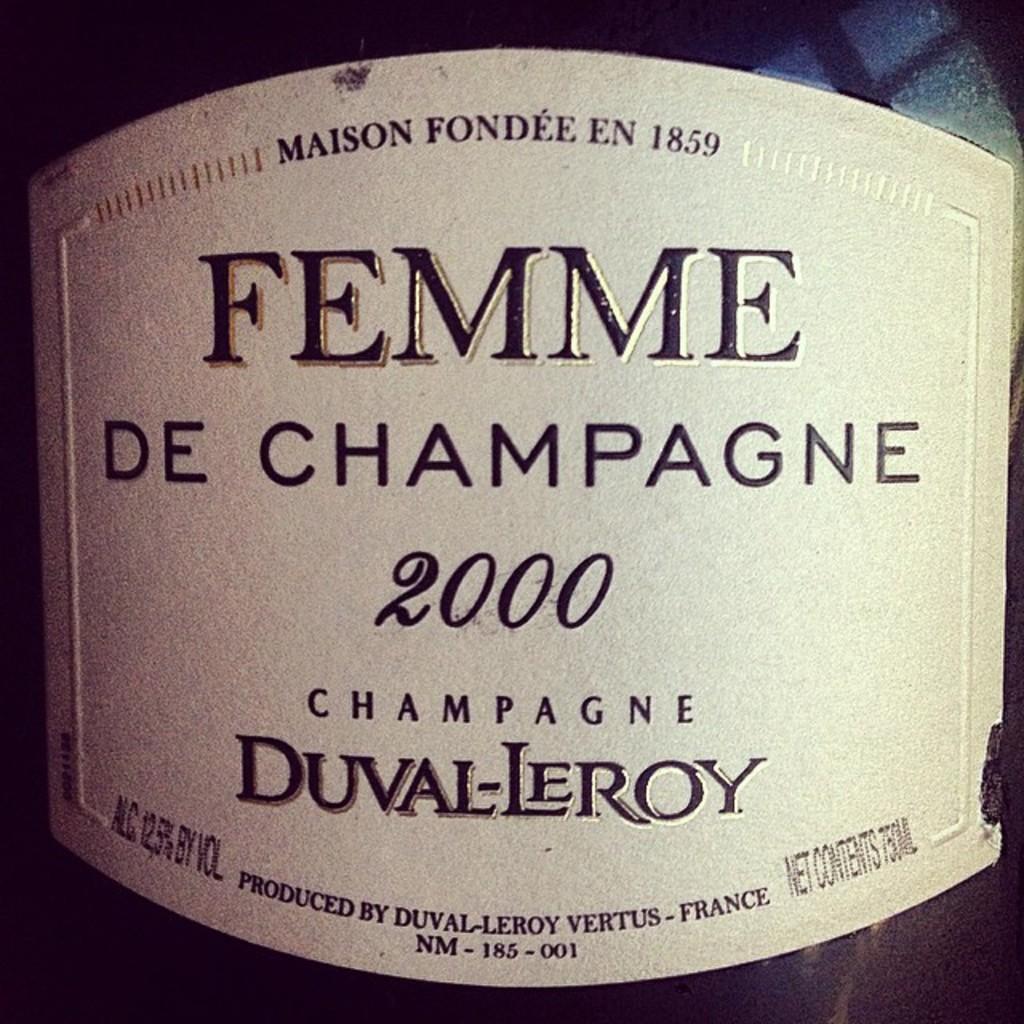Could you give a brief overview of what you see in this image? In this picture there is a poster, on the poster there are numbers and text. 